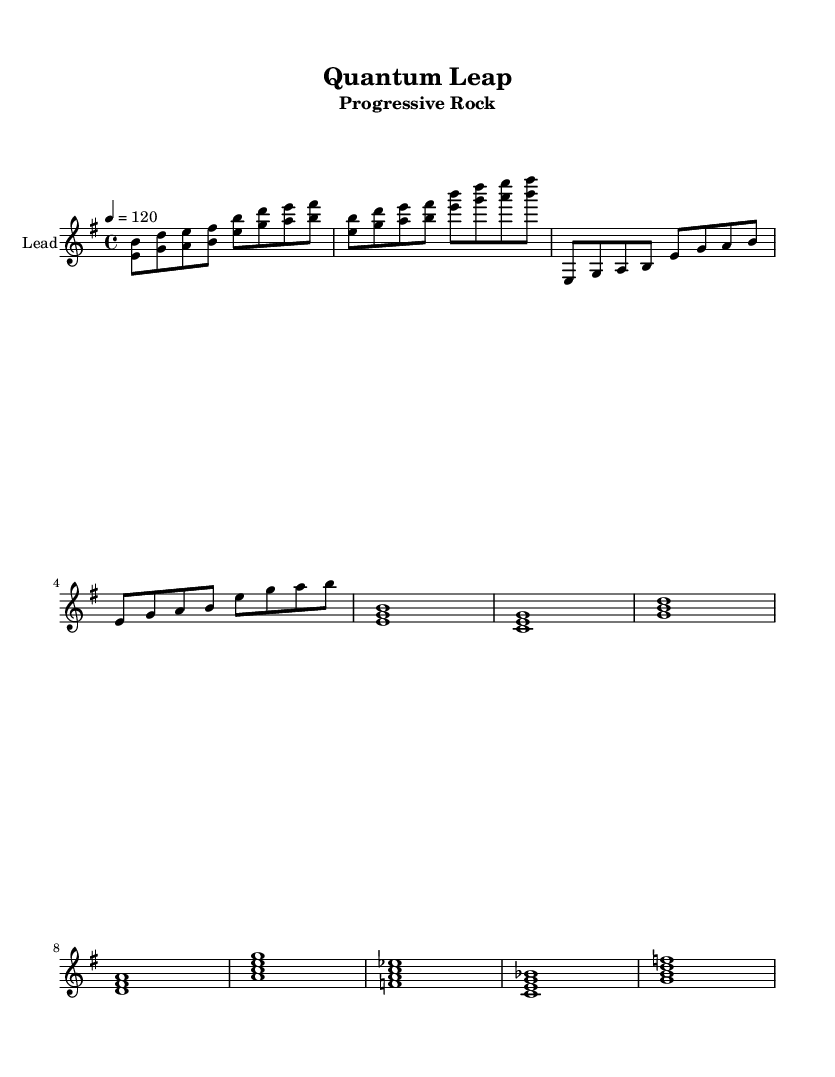What is the key signature of this music? The key signature is E minor, which has one sharp (F#). It can be identified by looking at the key signature section at the beginning of the sheet music, where the sharp is placed on the F line in the staff.
Answer: E minor What is the time signature of this music? The time signature is 4/4, which means there are four beats in each measure and the quarter note gets one beat. This is indicated at the beginning of the music next to the key signature.
Answer: 4/4 What is the tempo marking for this piece? The tempo marking is 120 beats per minute, which is indicated at the beginning of the sheet music with the instruction "4 = 120". This means that there are 120 quarter note beats in one minute.
Answer: 120 How many measures are in the melody section? The melody section includes an intro, verse, chorus, and bridge. Counting these sections and their respective measures gives a total of 10 measures. The breakdown of measures in the intro (2), verse (2), chorus (4), and bridge (2) confirms this total.
Answer: 10 What kind of song is "Quantum Leap"? "Quantum Leap" is categorized as Progressive Rock, which is specified in the subtitle of the sheet music. This genre is known for its complex compositions and experimental sounds.
Answer: Progressive Rock What is a notable theme in the lyrics of this song? The notable theme in the lyrics is the exploration of quantum mechanics and technological advancements. Phrases like "Quantum leap" and references to famous physicists indicate the focus on scientific discovery and progress.
Answer: Quantum mechanics What is the chord for the chorus section? The chord sequence for the chorus consists of E minor, C major, G major, and D major, each held for the duration of a whole note. These chords are specified in the chord mode section under the chorus part.
Answer: E minor, C major, G major, D major 